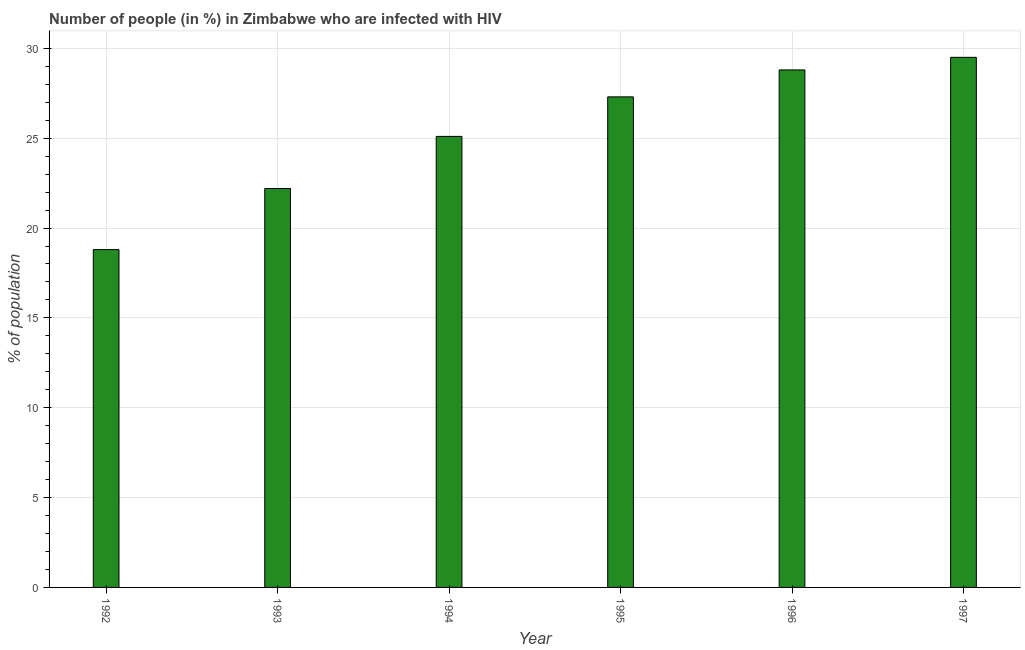What is the title of the graph?
Offer a terse response. Number of people (in %) in Zimbabwe who are infected with HIV. What is the label or title of the X-axis?
Your response must be concise. Year. What is the label or title of the Y-axis?
Your answer should be very brief. % of population. What is the number of people infected with hiv in 1997?
Your answer should be very brief. 29.5. Across all years, what is the maximum number of people infected with hiv?
Offer a very short reply. 29.5. In which year was the number of people infected with hiv maximum?
Offer a terse response. 1997. What is the sum of the number of people infected with hiv?
Give a very brief answer. 151.7. What is the difference between the number of people infected with hiv in 1993 and 1996?
Ensure brevity in your answer.  -6.6. What is the average number of people infected with hiv per year?
Your answer should be very brief. 25.28. What is the median number of people infected with hiv?
Your answer should be compact. 26.2. In how many years, is the number of people infected with hiv greater than 9 %?
Provide a succinct answer. 6. Do a majority of the years between 1993 and 1995 (inclusive) have number of people infected with hiv greater than 21 %?
Your answer should be very brief. Yes. What is the ratio of the number of people infected with hiv in 1995 to that in 1996?
Your response must be concise. 0.95. What is the difference between the highest and the lowest number of people infected with hiv?
Your answer should be very brief. 10.7. How many bars are there?
Ensure brevity in your answer.  6. How many years are there in the graph?
Offer a terse response. 6. What is the difference between two consecutive major ticks on the Y-axis?
Give a very brief answer. 5. Are the values on the major ticks of Y-axis written in scientific E-notation?
Provide a short and direct response. No. What is the % of population in 1992?
Your answer should be very brief. 18.8. What is the % of population of 1993?
Make the answer very short. 22.2. What is the % of population in 1994?
Your response must be concise. 25.1. What is the % of population in 1995?
Your answer should be compact. 27.3. What is the % of population in 1996?
Your response must be concise. 28.8. What is the % of population in 1997?
Ensure brevity in your answer.  29.5. What is the difference between the % of population in 1992 and 1993?
Your answer should be very brief. -3.4. What is the difference between the % of population in 1993 and 1996?
Offer a terse response. -6.6. What is the difference between the % of population in 1993 and 1997?
Keep it short and to the point. -7.3. What is the difference between the % of population in 1994 and 1996?
Offer a very short reply. -3.7. What is the difference between the % of population in 1994 and 1997?
Your answer should be very brief. -4.4. What is the difference between the % of population in 1995 and 1996?
Your answer should be very brief. -1.5. What is the ratio of the % of population in 1992 to that in 1993?
Provide a succinct answer. 0.85. What is the ratio of the % of population in 1992 to that in 1994?
Provide a short and direct response. 0.75. What is the ratio of the % of population in 1992 to that in 1995?
Keep it short and to the point. 0.69. What is the ratio of the % of population in 1992 to that in 1996?
Your response must be concise. 0.65. What is the ratio of the % of population in 1992 to that in 1997?
Provide a short and direct response. 0.64. What is the ratio of the % of population in 1993 to that in 1994?
Make the answer very short. 0.88. What is the ratio of the % of population in 1993 to that in 1995?
Offer a terse response. 0.81. What is the ratio of the % of population in 1993 to that in 1996?
Make the answer very short. 0.77. What is the ratio of the % of population in 1993 to that in 1997?
Your response must be concise. 0.75. What is the ratio of the % of population in 1994 to that in 1995?
Ensure brevity in your answer.  0.92. What is the ratio of the % of population in 1994 to that in 1996?
Your answer should be compact. 0.87. What is the ratio of the % of population in 1994 to that in 1997?
Your answer should be compact. 0.85. What is the ratio of the % of population in 1995 to that in 1996?
Make the answer very short. 0.95. What is the ratio of the % of population in 1995 to that in 1997?
Offer a very short reply. 0.93. What is the ratio of the % of population in 1996 to that in 1997?
Ensure brevity in your answer.  0.98. 